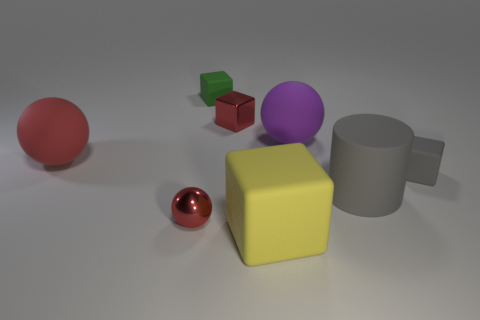What number of purple things are the same size as the metallic ball?
Provide a short and direct response. 0. Do the gray matte cylinder in front of the big purple matte ball and the rubber ball that is to the left of the yellow object have the same size?
Keep it short and to the point. Yes. What shape is the small thing that is in front of the tiny red metallic cube and on the left side of the big yellow object?
Provide a short and direct response. Sphere. Is there a shiny cube that has the same color as the large cylinder?
Offer a terse response. No. Are there any cyan metal things?
Your answer should be very brief. No. There is a tiny rubber cube that is behind the big purple matte thing; what color is it?
Ensure brevity in your answer.  Green. Does the yellow object have the same size as the rubber block behind the gray cube?
Offer a very short reply. No. How big is the matte block that is behind the big rubber cube and in front of the red matte object?
Provide a succinct answer. Small. Is there a tiny gray cube that has the same material as the big purple sphere?
Ensure brevity in your answer.  Yes. The tiny green matte object is what shape?
Your answer should be compact. Cube. 